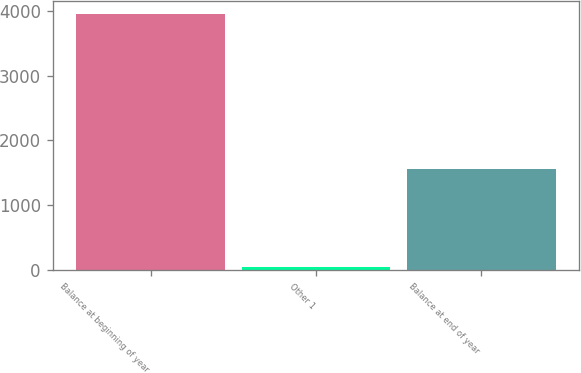Convert chart. <chart><loc_0><loc_0><loc_500><loc_500><bar_chart><fcel>Balance at beginning of year<fcel>Other 1<fcel>Balance at end of year<nl><fcel>3952<fcel>53<fcel>1562<nl></chart> 